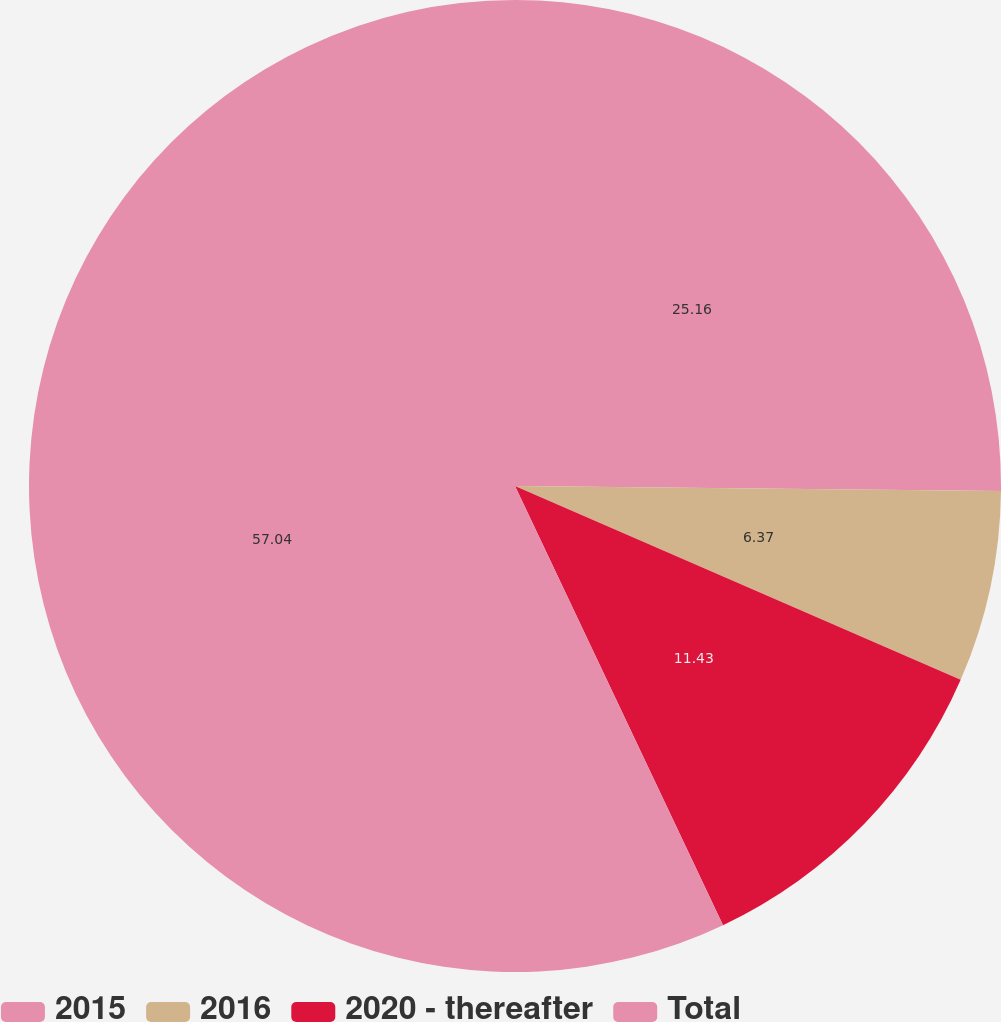Convert chart. <chart><loc_0><loc_0><loc_500><loc_500><pie_chart><fcel>2015<fcel>2016<fcel>2020 - thereafter<fcel>Total<nl><fcel>25.16%<fcel>6.37%<fcel>11.43%<fcel>57.04%<nl></chart> 